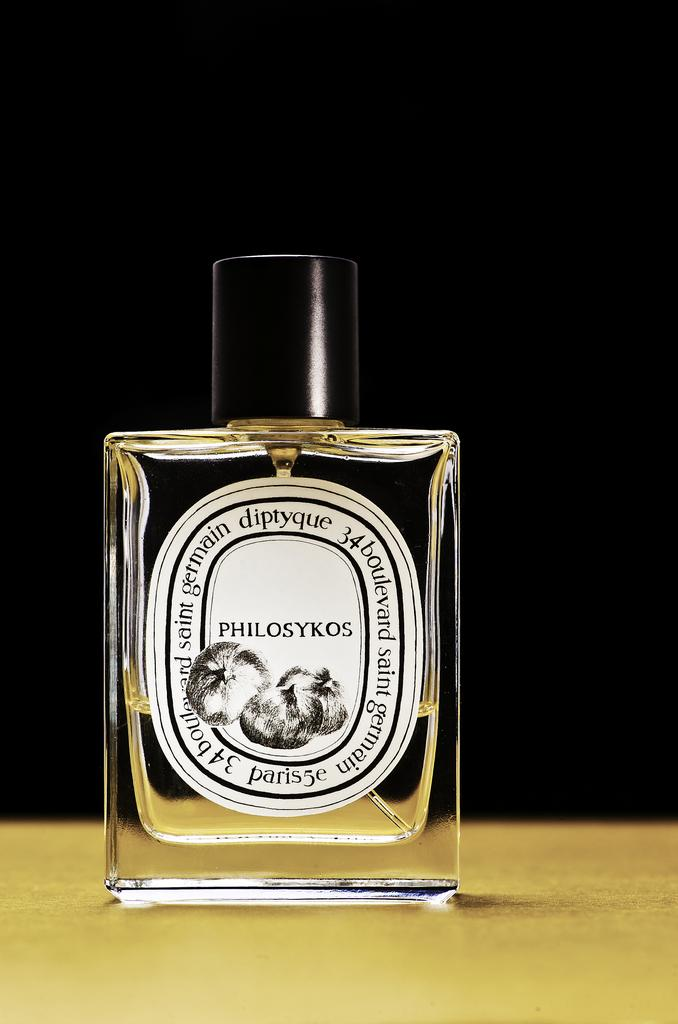What object is placed on the table in the image? There is a bottle on the table. Can you see any fangs or wounds on the bottle in the image? No, there are no fangs or wounds present on the bottle in the image. 